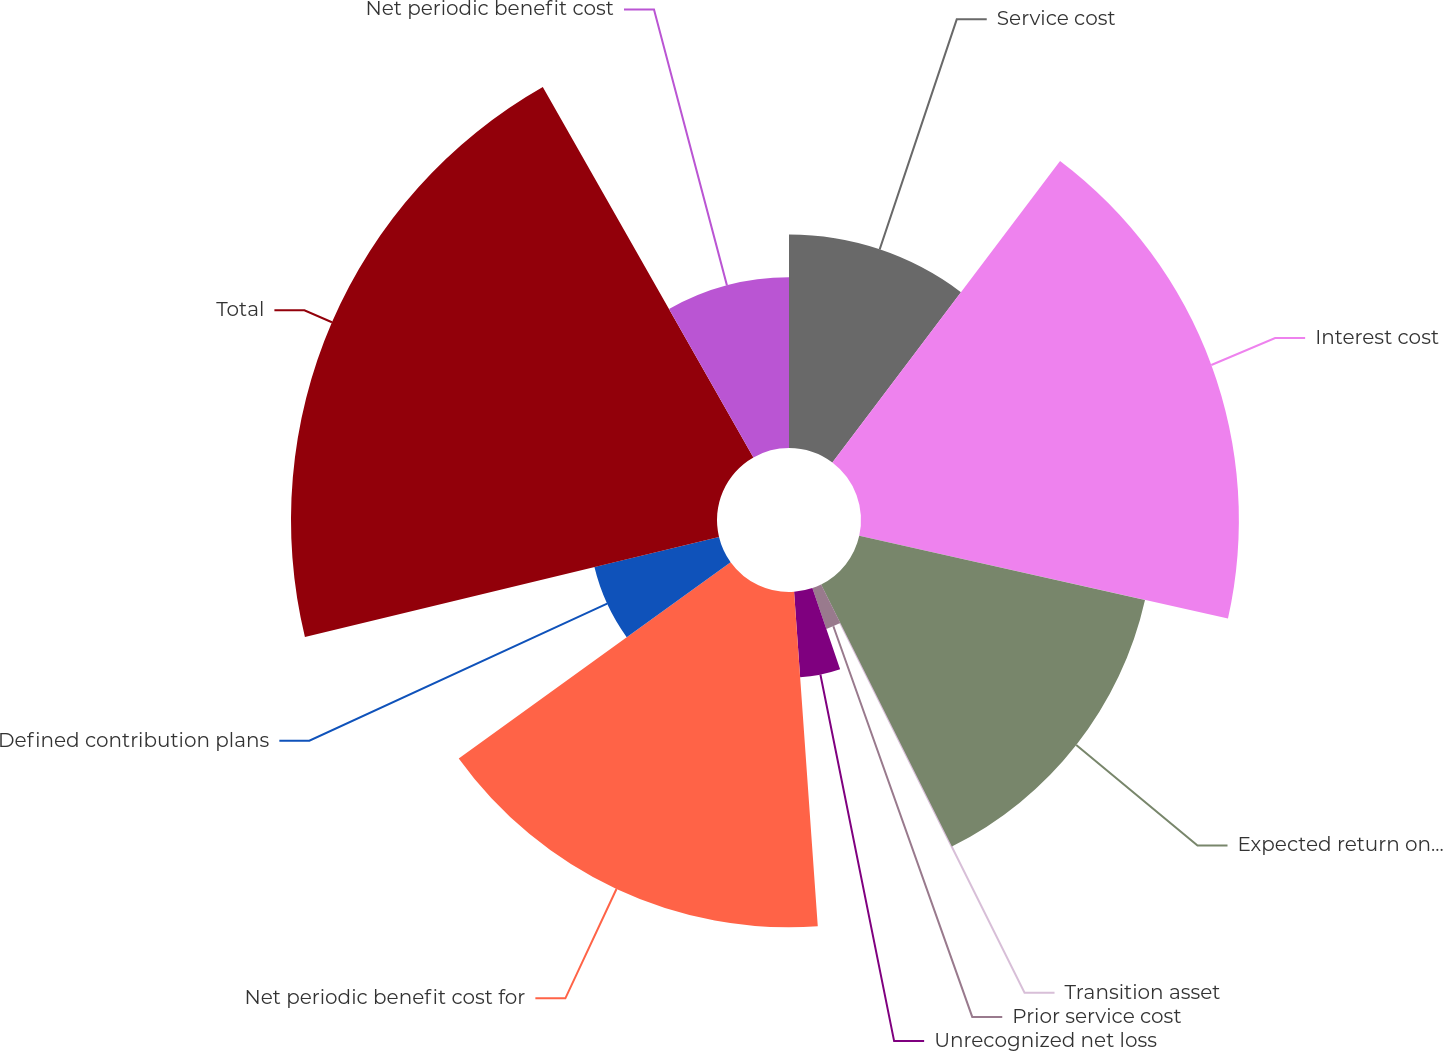Convert chart. <chart><loc_0><loc_0><loc_500><loc_500><pie_chart><fcel>Service cost<fcel>Interest cost<fcel>Expected return on assets<fcel>Transition asset<fcel>Prior service cost<fcel>Unrecognized net loss<fcel>Net periodic benefit cost for<fcel>Defined contribution plans<fcel>Total<fcel>Net periodic benefit cost<nl><fcel>10.29%<fcel>18.22%<fcel>14.12%<fcel>0.03%<fcel>2.08%<fcel>4.13%<fcel>16.17%<fcel>6.18%<fcel>20.54%<fcel>8.23%<nl></chart> 